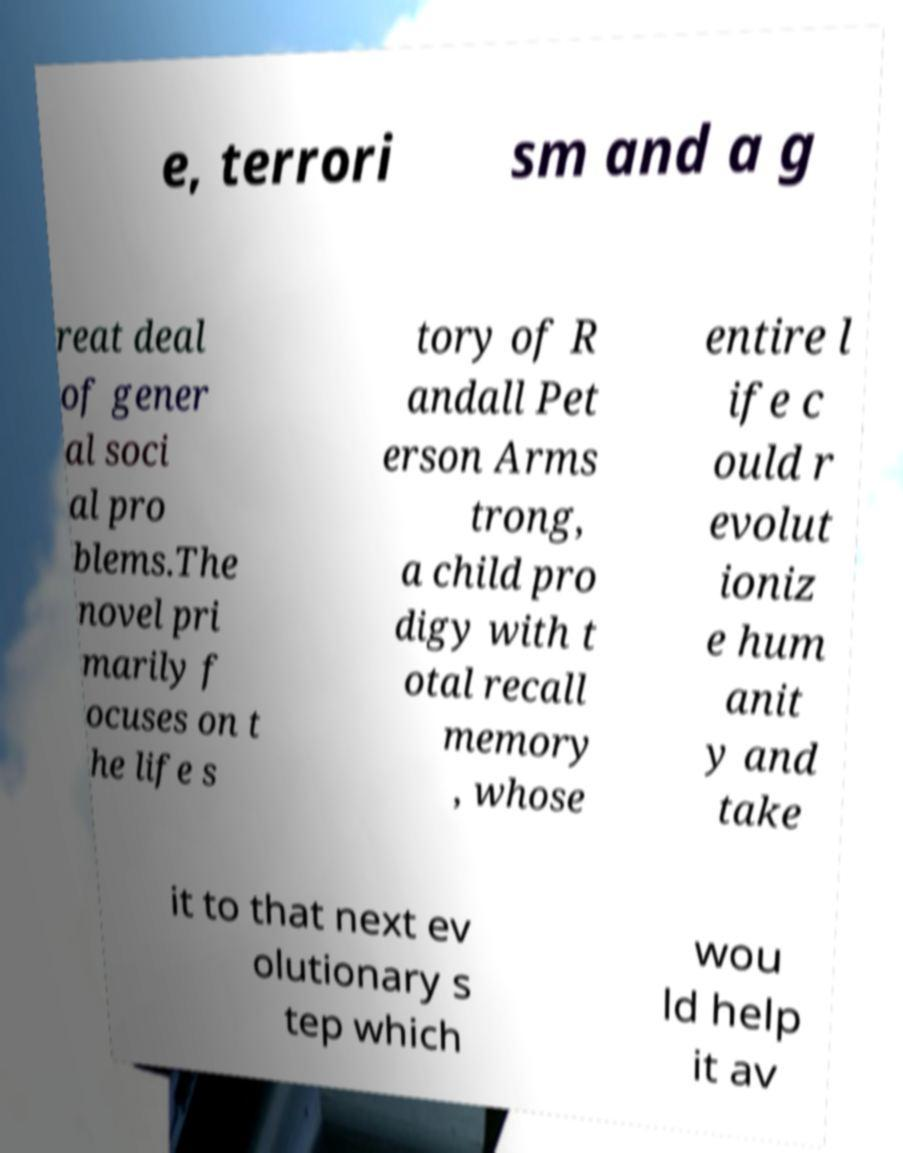Please read and relay the text visible in this image. What does it say? e, terrori sm and a g reat deal of gener al soci al pro blems.The novel pri marily f ocuses on t he life s tory of R andall Pet erson Arms trong, a child pro digy with t otal recall memory , whose entire l ife c ould r evolut ioniz e hum anit y and take it to that next ev olutionary s tep which wou ld help it av 